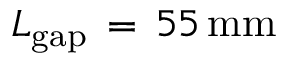Convert formula to latex. <formula><loc_0><loc_0><loc_500><loc_500>L _ { g a p } \, = \, 5 5 \, { m m }</formula> 